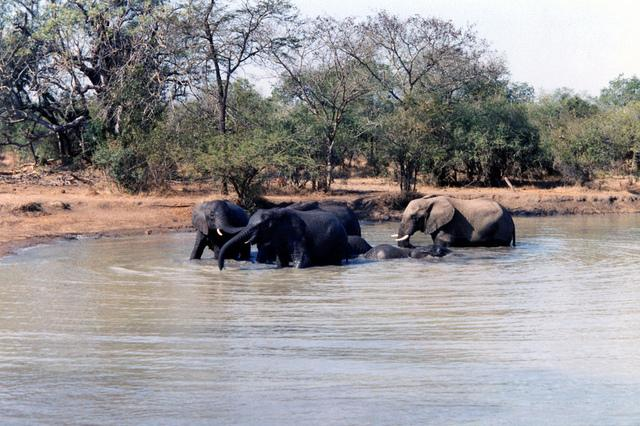What do the animals all have? Please explain your reasoning. tusks. The elephants all contain two tusks each. 